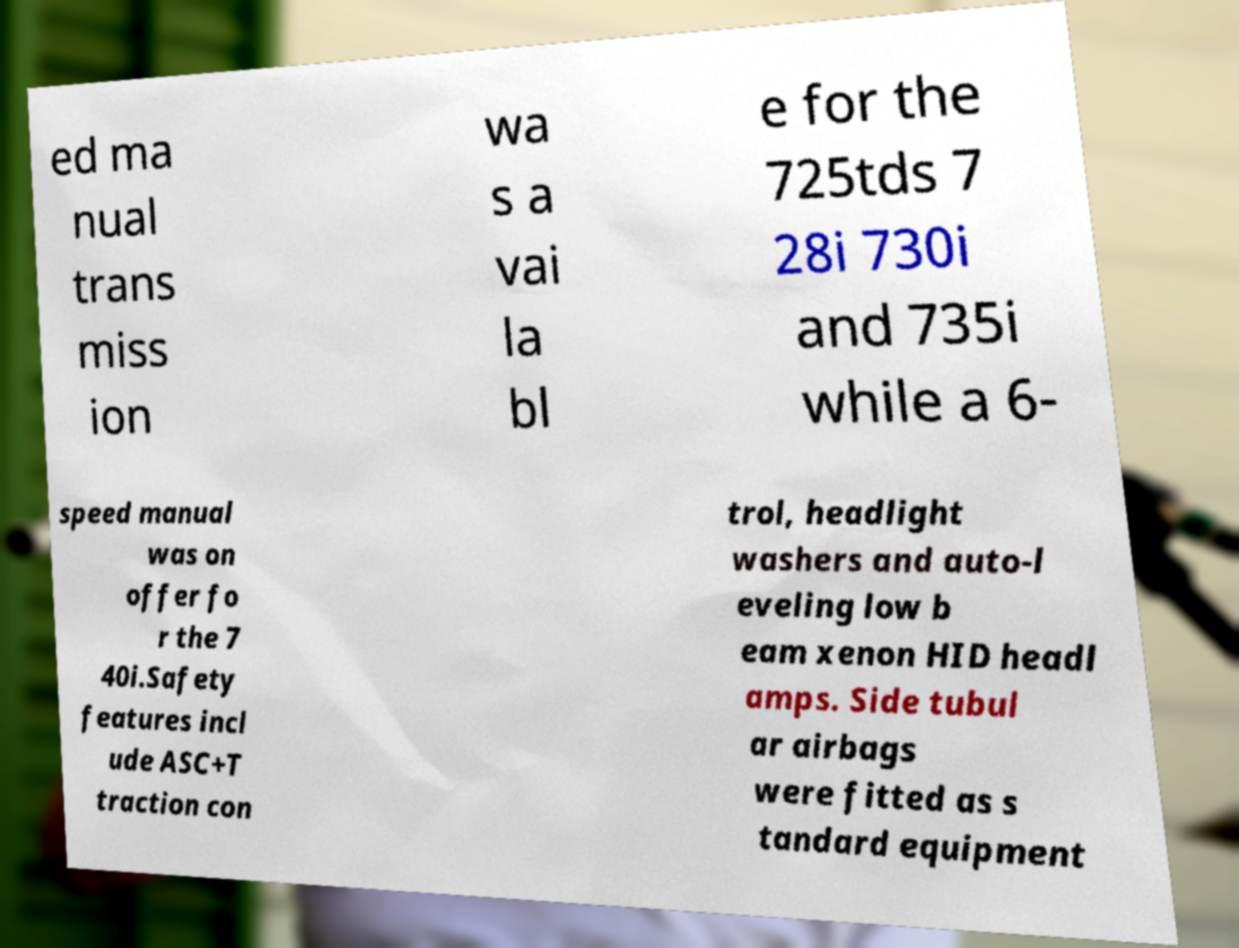Please identify and transcribe the text found in this image. ed ma nual trans miss ion wa s a vai la bl e for the 725tds 7 28i 730i and 735i while a 6- speed manual was on offer fo r the 7 40i.Safety features incl ude ASC+T traction con trol, headlight washers and auto-l eveling low b eam xenon HID headl amps. Side tubul ar airbags were fitted as s tandard equipment 